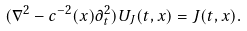<formula> <loc_0><loc_0><loc_500><loc_500>( \nabla ^ { 2 } - c ^ { - 2 } ( x ) \partial _ { t } ^ { 2 } ) U _ { J } ( t , x ) = J ( t , x ) .</formula> 